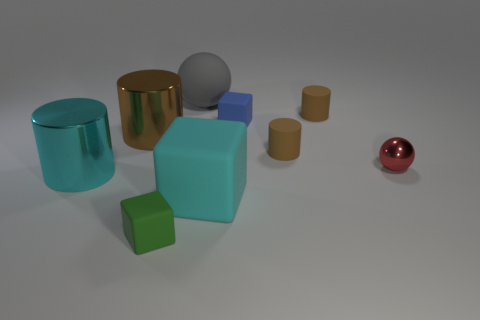Is the brown object on the left side of the blue object made of the same material as the small red ball?
Your response must be concise. Yes. Is the number of large cyan blocks behind the big cyan matte object less than the number of tiny things that are behind the big cyan cylinder?
Provide a short and direct response. Yes. How many other objects are there of the same material as the red object?
Offer a very short reply. 2. There is a cyan cylinder that is the same size as the gray rubber sphere; what material is it?
Your response must be concise. Metal. Is the number of metallic cylinders that are behind the metal ball less than the number of large brown cylinders?
Give a very brief answer. No. The large rubber object that is in front of the big matte thing that is behind the tiny matte cube that is behind the small green rubber object is what shape?
Your response must be concise. Cube. What is the size of the metal cylinder that is behind the shiny ball?
Ensure brevity in your answer.  Large. What shape is the metal thing that is the same size as the blue rubber thing?
Offer a terse response. Sphere. What number of things are tiny matte objects or large metal cylinders that are in front of the tiny red object?
Offer a very short reply. 5. What number of big gray rubber things are behind the sphere in front of the ball that is behind the red shiny sphere?
Offer a very short reply. 1. 